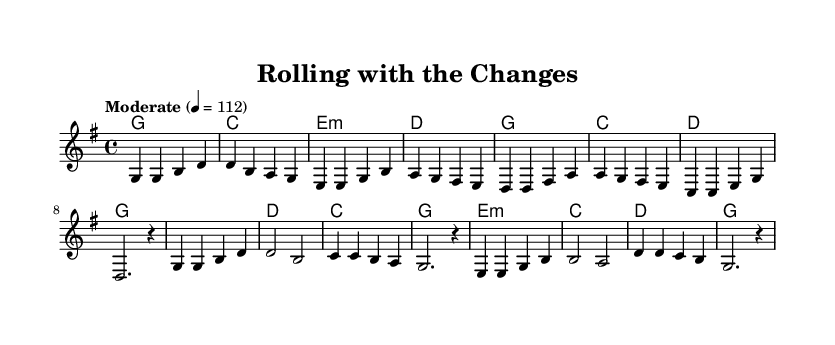What is the key signature of this music? The key signature is G major, which has one sharp (F#).
Answer: G major What is the time signature of the piece? The time signature is 4/4, indicating four beats in each measure.
Answer: 4/4 What is the tempo marking? The tempo marking is "Moderate" at a quarter note equals 112 beats per minute.
Answer: Moderate 4 = 112 How many measures are in the verse? The verse consists of 8 measures, as counted from the melody section before the chorus begins.
Answer: 8 In which section do the harmonies change from G major to C major? The harmonies change from G major to C major at the beginning of the verse, specifically in the second measure.
Answer: Second measure What is the highest note in the melody? The highest note in the melody is D, which appears in both the verse and chorus sections.
Answer: D Does the piece include a chorus? Yes, the piece includes a chorus following the verse, clearly indicated in the structure of the sheet music.
Answer: Yes 